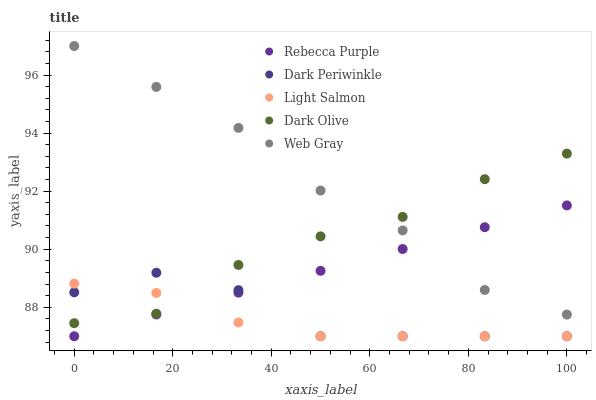Does Light Salmon have the minimum area under the curve?
Answer yes or no. Yes. Does Web Gray have the maximum area under the curve?
Answer yes or no. Yes. Does Dark Olive have the minimum area under the curve?
Answer yes or no. No. Does Dark Olive have the maximum area under the curve?
Answer yes or no. No. Is Rebecca Purple the smoothest?
Answer yes or no. Yes. Is Dark Periwinkle the roughest?
Answer yes or no. Yes. Is Dark Olive the smoothest?
Answer yes or no. No. Is Dark Olive the roughest?
Answer yes or no. No. Does Light Salmon have the lowest value?
Answer yes or no. Yes. Does Dark Olive have the lowest value?
Answer yes or no. No. Does Web Gray have the highest value?
Answer yes or no. Yes. Does Dark Olive have the highest value?
Answer yes or no. No. Is Dark Periwinkle less than Web Gray?
Answer yes or no. Yes. Is Web Gray greater than Dark Periwinkle?
Answer yes or no. Yes. Does Dark Periwinkle intersect Dark Olive?
Answer yes or no. Yes. Is Dark Periwinkle less than Dark Olive?
Answer yes or no. No. Is Dark Periwinkle greater than Dark Olive?
Answer yes or no. No. Does Dark Periwinkle intersect Web Gray?
Answer yes or no. No. 